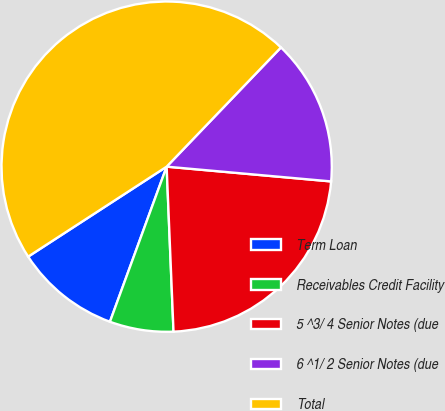Convert chart to OTSL. <chart><loc_0><loc_0><loc_500><loc_500><pie_chart><fcel>Term Loan<fcel>Receivables Credit Facility<fcel>5 ^3/ 4 Senior Notes (due<fcel>6 ^1/ 2 Senior Notes (due<fcel>Total<nl><fcel>10.25%<fcel>6.24%<fcel>22.91%<fcel>14.26%<fcel>46.33%<nl></chart> 